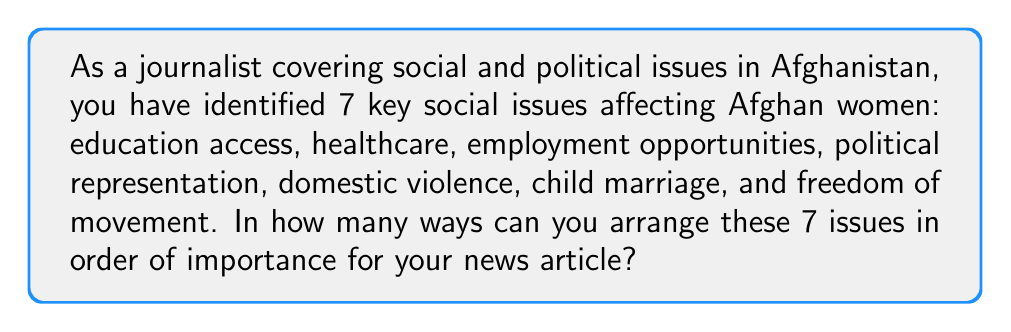Solve this math problem. To solve this problem, we need to use the concept of permutations. Since we are arranging all 7 issues in a specific order, and each issue can only be used once, this is a straightforward permutation problem.

The number of permutations of n distinct objects is given by the formula:

$$ P(n) = n! $$

Where $n!$ represents the factorial of n.

In this case, we have 7 distinct issues to arrange:

$$ P(7) = 7! $$

Let's calculate this step-by-step:

$$ 7! = 7 \times 6 \times 5 \times 4 \times 3 \times 2 \times 1 $$

$$ = 5040 $$

Therefore, there are 5040 different ways to arrange these 7 key social issues in order of importance for the news article.
Answer: $7! = 5040$ 